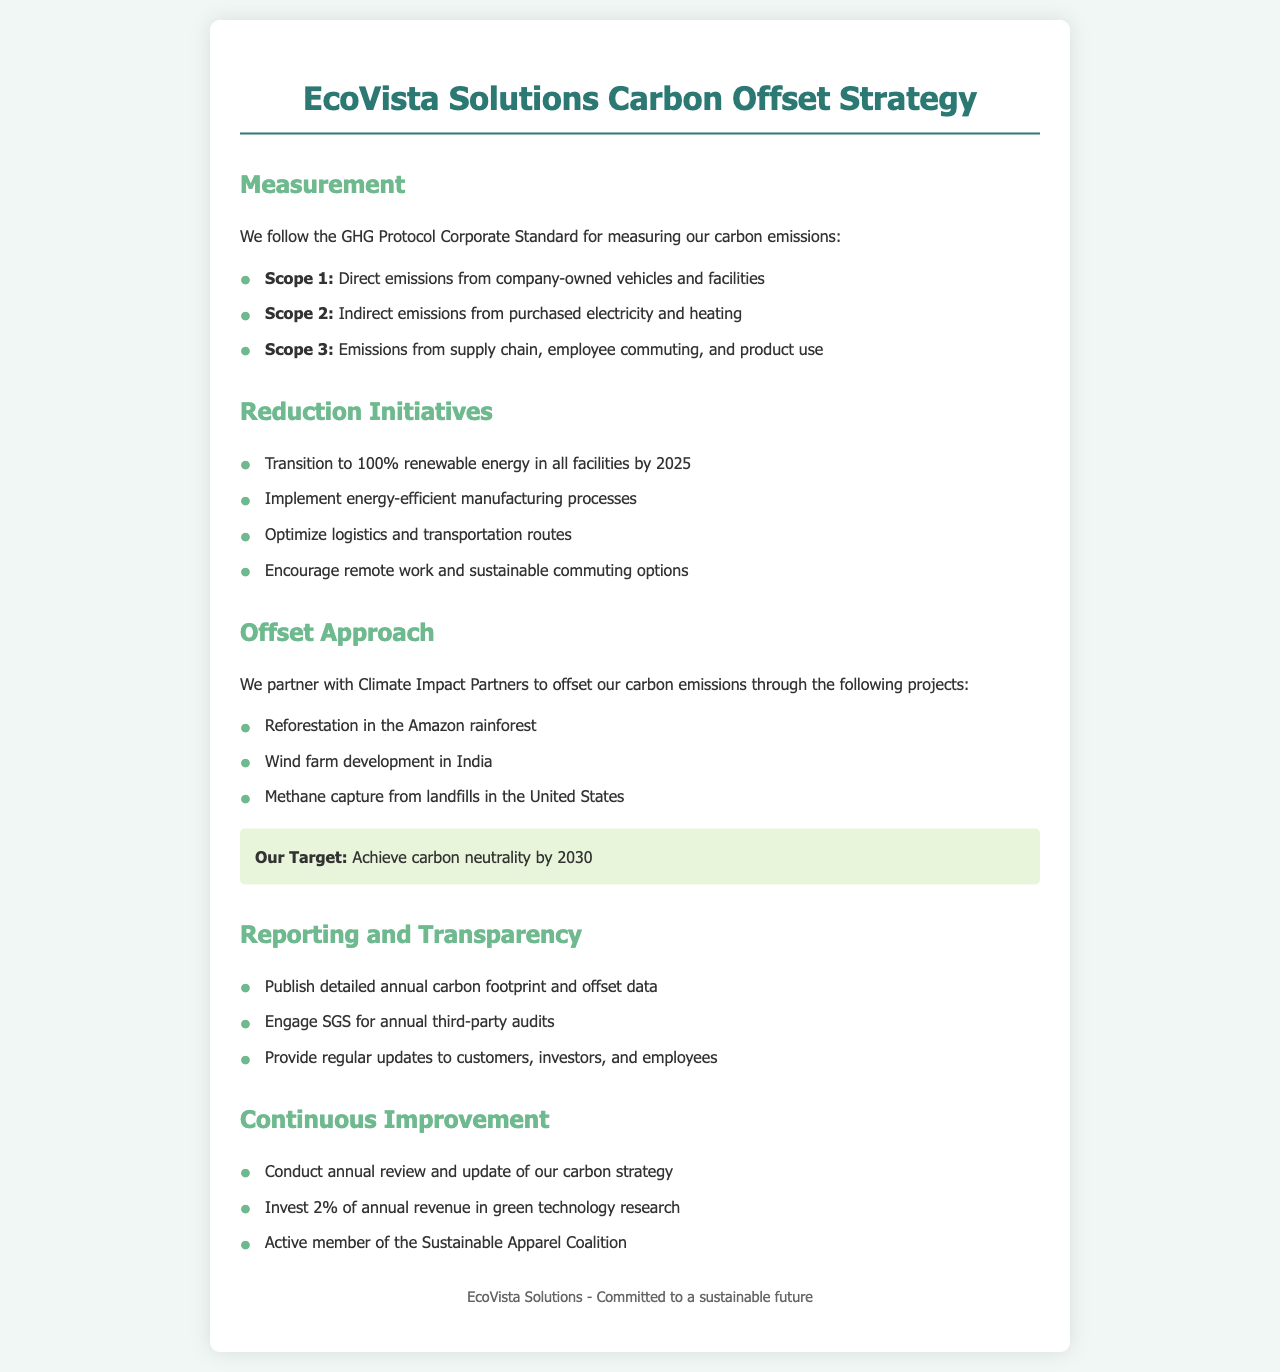What emissions framework does EcoVista Solutions follow? The document states that EcoVista Solutions follows the GHG Protocol Corporate Standard for measuring their carbon emissions.
Answer: GHG Protocol Corporate Standard What is EcoVista Solutions' target year for achieving carbon neutrality? The document specifies that their target is to achieve carbon neutrality by 2030.
Answer: 2030 What is a reduction initiative mentioned in the document? The document lists several reduction initiatives, one of which is to transition to 100% renewable energy in all facilities by 2025.
Answer: Transition to 100% renewable energy Who does EcoVista Solutions partner with for carbon offset projects? The document states that EcoVista Solutions partners with Climate Impact Partners for their carbon offset projects.
Answer: Climate Impact Partners What percentage of annual revenue does EcoVista Solutions invest in green technology research? The document mentions that EcoVista Solutions invests 2% of their annual revenue in green technology research.
Answer: 2% What type of projects does EcoVista Solutions support for carbon offsetting? The document lists several projects, one example being reforestation in the Amazon rainforest.
Answer: Reforestation in the Amazon rainforest 